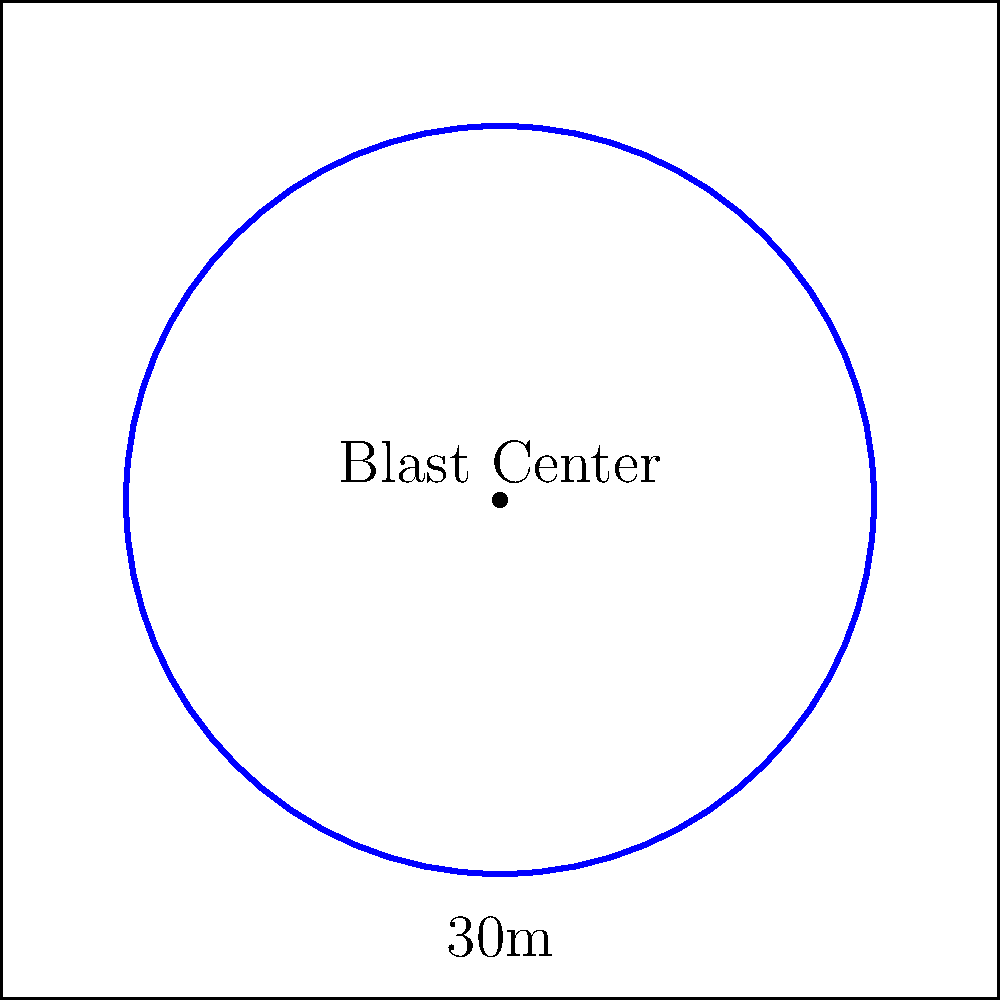During a controlled demolition at an old mining site, a circular blast zone is created. If the radius of this blast zone is 30 meters, what is the total area affected by the blast? Round your answer to the nearest square meter. To solve this problem, we need to use the formula for the area of a circle:

$$ A = \pi r^2 $$

Where:
$A$ is the area of the circle
$\pi$ (pi) is approximately 3.14159
$r$ is the radius of the circle

Given:
- The radius of the blast zone is 30 meters

Step 1: Substitute the given radius into the formula
$$ A = \pi (30)^2 $$

Step 2: Calculate the square of the radius
$$ A = \pi (900) $$

Step 3: Multiply by pi
$$ A = 2,827.43... \text{ square meters} $$

Step 4: Round to the nearest square meter
$$ A \approx 2,827 \text{ square meters} $$

Therefore, the total area affected by the blast is approximately 2,827 square meters.
Answer: 2,827 square meters 